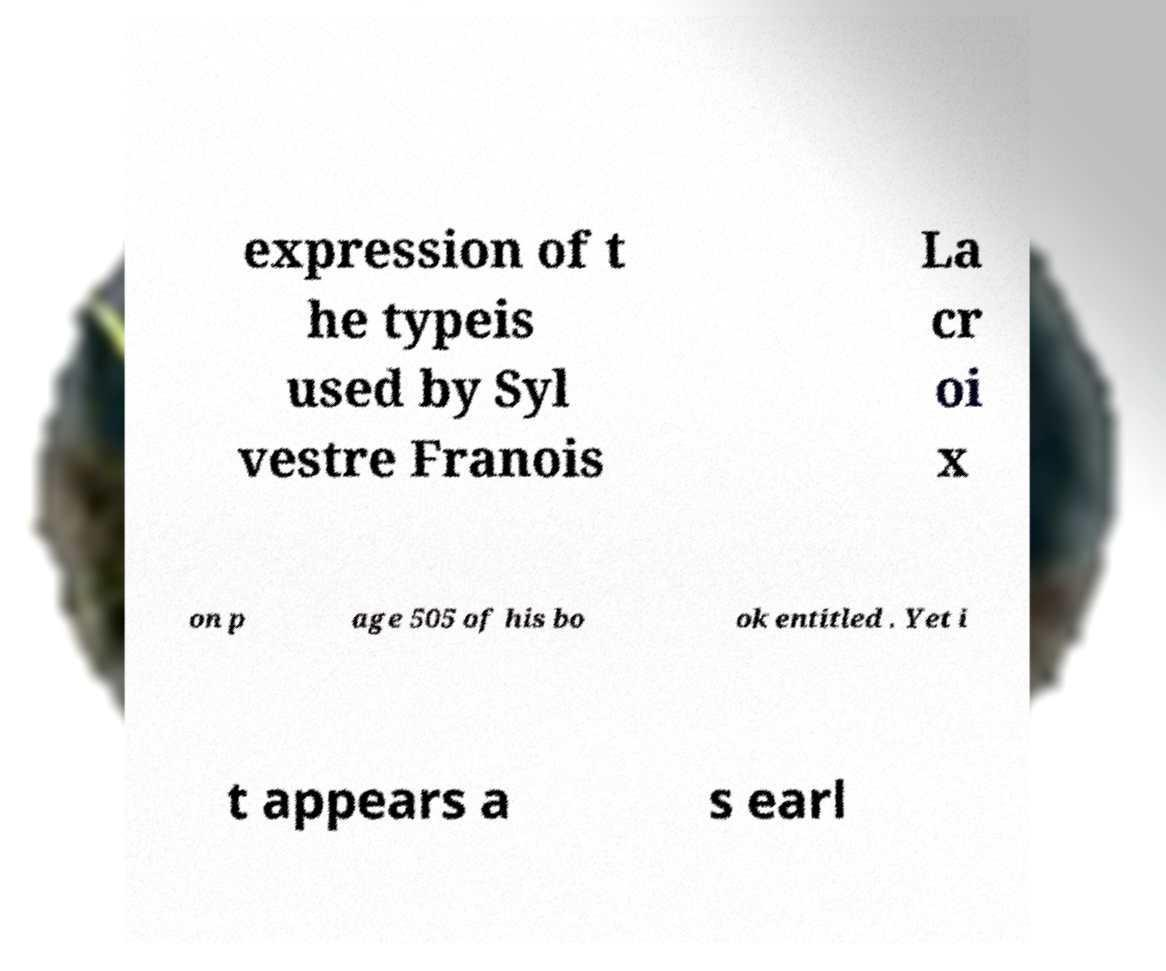Could you extract and type out the text from this image? expression of t he typeis used by Syl vestre Franois La cr oi x on p age 505 of his bo ok entitled . Yet i t appears a s earl 